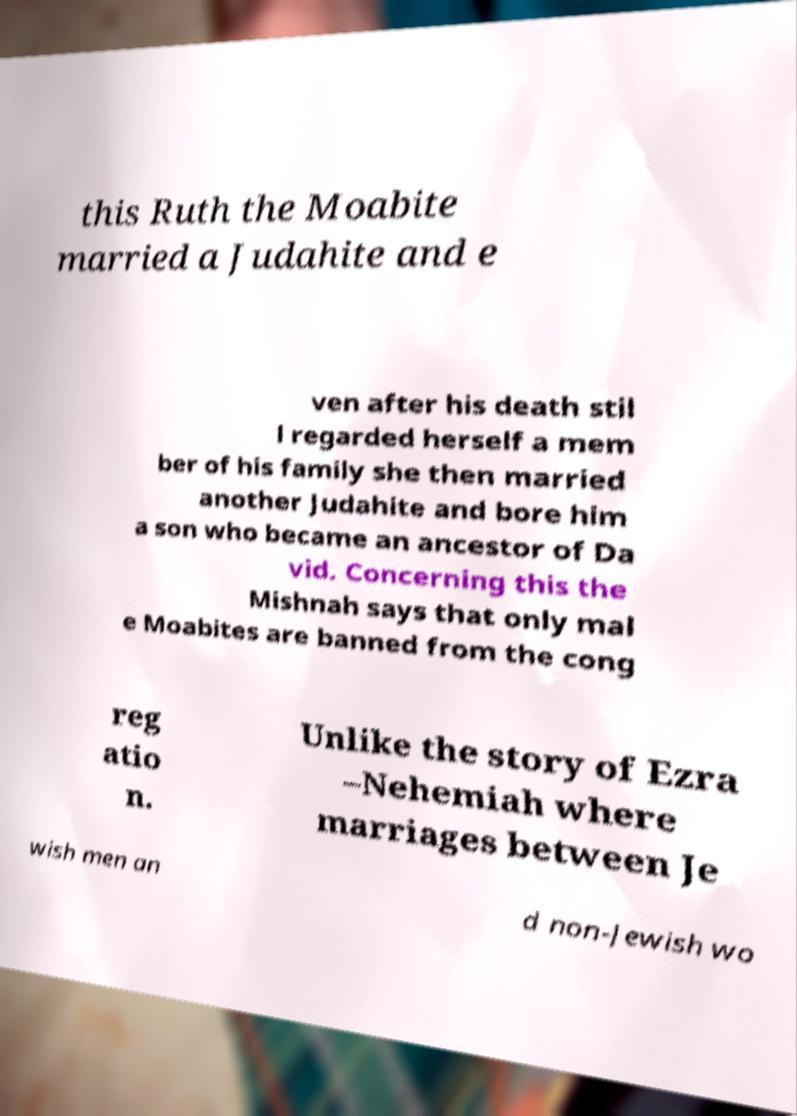Could you assist in decoding the text presented in this image and type it out clearly? this Ruth the Moabite married a Judahite and e ven after his death stil l regarded herself a mem ber of his family she then married another Judahite and bore him a son who became an ancestor of Da vid. Concerning this the Mishnah says that only mal e Moabites are banned from the cong reg atio n. Unlike the story of Ezra –Nehemiah where marriages between Je wish men an d non-Jewish wo 